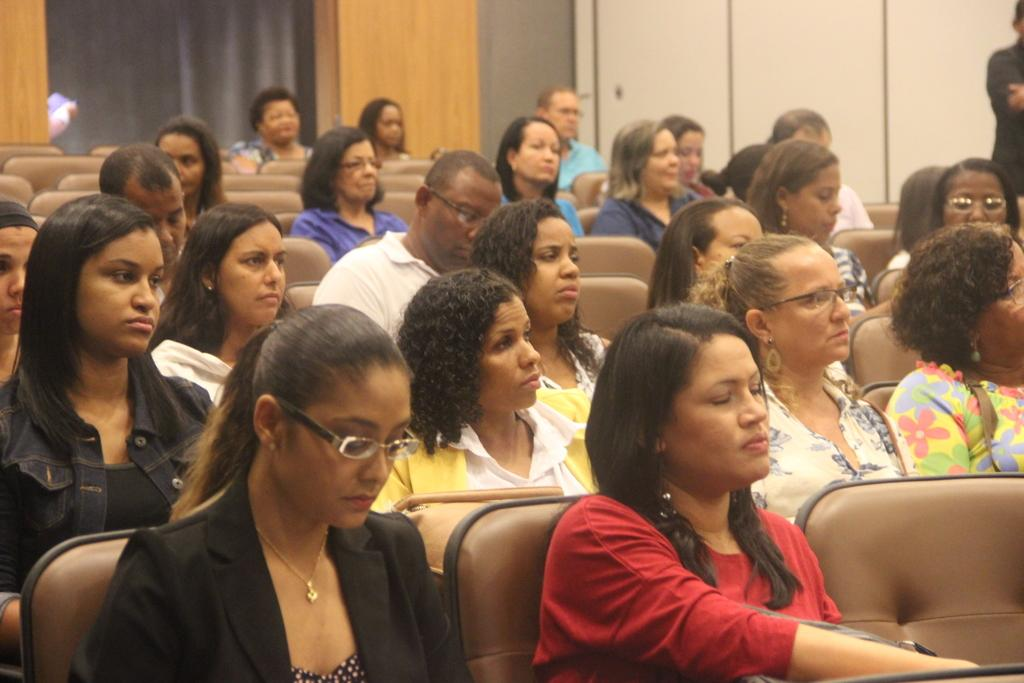How many people are sitting on the chair in the image? There is a group of persons sitting on a chair in the image. What is the position of the person on the right side? There is a person standing on the right side in the image. What color is the curtain in the background? The curtain in the background is black. What type of song is being sung by the person sitting on the chair? There is no indication in the image that a song is being sung, so it cannot be determined from the picture. What reward is being given to the person standing on the right side? There is no reward visible in the image, and the person standing on the right side is not receiving anything. 